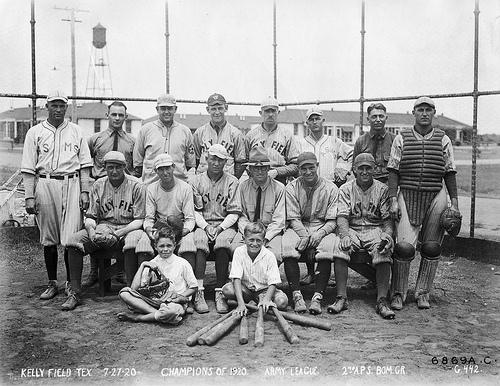Question: who is wearing different clothes?
Choices:
A. The keeper.
B. The skier.
C. The skateboarder.
D. The tennis player.
Answer with the letter. Answer: A Question: what is the color of the photo?
Choices:
A. Purple.
B. Blue.
C. Red.
D. Gray.
Answer with the letter. Answer: D Question: what has been kept on the ground?
Choices:
A. The bat.
B. The purse.
C. The baby.
D. The dog.
Answer with the letter. Answer: A Question: what is the color of the uniform?
Choices:
A. White.
B. Black.
C. Red.
D. Orange.
Answer with the letter. Answer: A Question: when was the pic taken?
Choices:
A. In summer.
B. In winter.
C. 1920.
D. In autumn.
Answer with the letter. Answer: C 